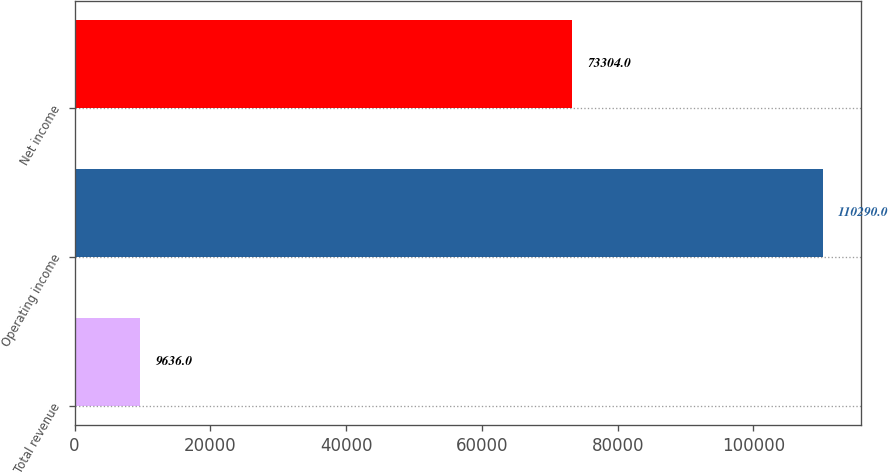Convert chart. <chart><loc_0><loc_0><loc_500><loc_500><bar_chart><fcel>Total revenue<fcel>Operating income<fcel>Net income<nl><fcel>9636<fcel>110290<fcel>73304<nl></chart> 